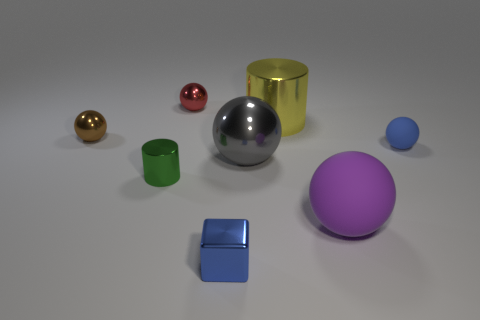Subtract 2 balls. How many balls are left? 3 Subtract all purple spheres. How many spheres are left? 4 Subtract all red spheres. How many spheres are left? 4 Subtract all red spheres. Subtract all brown blocks. How many spheres are left? 4 Add 1 things. How many objects exist? 9 Subtract all balls. How many objects are left? 3 Subtract all small brown metal objects. Subtract all green shiny objects. How many objects are left? 6 Add 8 cubes. How many cubes are left? 9 Add 3 tiny green objects. How many tiny green objects exist? 4 Subtract 0 gray cubes. How many objects are left? 8 